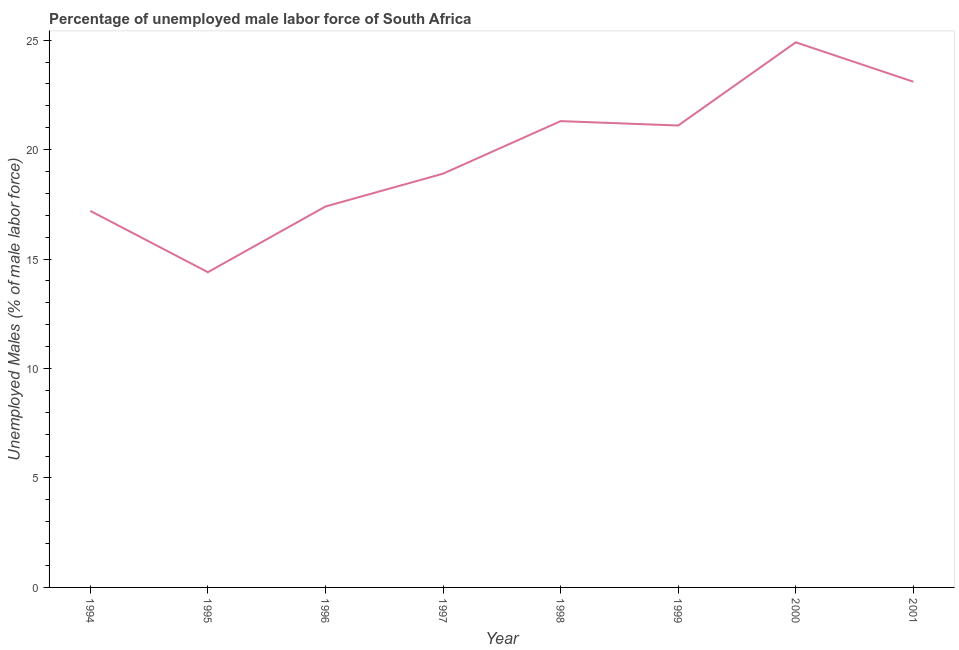What is the total unemployed male labour force in 1999?
Your response must be concise. 21.1. Across all years, what is the maximum total unemployed male labour force?
Your answer should be compact. 24.9. Across all years, what is the minimum total unemployed male labour force?
Offer a terse response. 14.4. In which year was the total unemployed male labour force minimum?
Make the answer very short. 1995. What is the sum of the total unemployed male labour force?
Offer a very short reply. 158.3. What is the difference between the total unemployed male labour force in 1998 and 1999?
Provide a short and direct response. 0.2. What is the average total unemployed male labour force per year?
Offer a terse response. 19.79. What is the median total unemployed male labour force?
Provide a short and direct response. 20. In how many years, is the total unemployed male labour force greater than 7 %?
Your answer should be compact. 8. Do a majority of the years between 1995 and 2000 (inclusive) have total unemployed male labour force greater than 19 %?
Your answer should be very brief. No. What is the ratio of the total unemployed male labour force in 1996 to that in 1997?
Provide a short and direct response. 0.92. Is the total unemployed male labour force in 1994 less than that in 1998?
Make the answer very short. Yes. What is the difference between the highest and the second highest total unemployed male labour force?
Offer a very short reply. 1.8. Is the sum of the total unemployed male labour force in 1996 and 1998 greater than the maximum total unemployed male labour force across all years?
Your answer should be compact. Yes. What is the difference between the highest and the lowest total unemployed male labour force?
Offer a terse response. 10.5. In how many years, is the total unemployed male labour force greater than the average total unemployed male labour force taken over all years?
Your answer should be compact. 4. What is the difference between two consecutive major ticks on the Y-axis?
Provide a short and direct response. 5. Does the graph contain any zero values?
Your answer should be compact. No. What is the title of the graph?
Your answer should be very brief. Percentage of unemployed male labor force of South Africa. What is the label or title of the X-axis?
Offer a very short reply. Year. What is the label or title of the Y-axis?
Offer a very short reply. Unemployed Males (% of male labor force). What is the Unemployed Males (% of male labor force) in 1994?
Provide a succinct answer. 17.2. What is the Unemployed Males (% of male labor force) in 1995?
Your answer should be compact. 14.4. What is the Unemployed Males (% of male labor force) of 1996?
Ensure brevity in your answer.  17.4. What is the Unemployed Males (% of male labor force) in 1997?
Your response must be concise. 18.9. What is the Unemployed Males (% of male labor force) in 1998?
Make the answer very short. 21.3. What is the Unemployed Males (% of male labor force) of 1999?
Keep it short and to the point. 21.1. What is the Unemployed Males (% of male labor force) in 2000?
Offer a very short reply. 24.9. What is the Unemployed Males (% of male labor force) in 2001?
Keep it short and to the point. 23.1. What is the difference between the Unemployed Males (% of male labor force) in 1994 and 1996?
Make the answer very short. -0.2. What is the difference between the Unemployed Males (% of male labor force) in 1994 and 1997?
Your response must be concise. -1.7. What is the difference between the Unemployed Males (% of male labor force) in 1994 and 1998?
Offer a very short reply. -4.1. What is the difference between the Unemployed Males (% of male labor force) in 1994 and 1999?
Provide a short and direct response. -3.9. What is the difference between the Unemployed Males (% of male labor force) in 1994 and 2001?
Make the answer very short. -5.9. What is the difference between the Unemployed Males (% of male labor force) in 1995 and 1996?
Offer a very short reply. -3. What is the difference between the Unemployed Males (% of male labor force) in 1995 and 1997?
Your response must be concise. -4.5. What is the difference between the Unemployed Males (% of male labor force) in 1995 and 1998?
Your response must be concise. -6.9. What is the difference between the Unemployed Males (% of male labor force) in 1995 and 1999?
Make the answer very short. -6.7. What is the difference between the Unemployed Males (% of male labor force) in 1995 and 2001?
Give a very brief answer. -8.7. What is the difference between the Unemployed Males (% of male labor force) in 1996 and 1998?
Ensure brevity in your answer.  -3.9. What is the difference between the Unemployed Males (% of male labor force) in 1996 and 2000?
Make the answer very short. -7.5. What is the difference between the Unemployed Males (% of male labor force) in 1997 and 1998?
Your response must be concise. -2.4. What is the difference between the Unemployed Males (% of male labor force) in 1997 and 1999?
Provide a succinct answer. -2.2. What is the difference between the Unemployed Males (% of male labor force) in 1997 and 2001?
Keep it short and to the point. -4.2. What is the difference between the Unemployed Males (% of male labor force) in 1998 and 1999?
Provide a short and direct response. 0.2. What is the difference between the Unemployed Males (% of male labor force) in 1999 and 2000?
Your response must be concise. -3.8. What is the ratio of the Unemployed Males (% of male labor force) in 1994 to that in 1995?
Give a very brief answer. 1.19. What is the ratio of the Unemployed Males (% of male labor force) in 1994 to that in 1996?
Your answer should be compact. 0.99. What is the ratio of the Unemployed Males (% of male labor force) in 1994 to that in 1997?
Make the answer very short. 0.91. What is the ratio of the Unemployed Males (% of male labor force) in 1994 to that in 1998?
Offer a very short reply. 0.81. What is the ratio of the Unemployed Males (% of male labor force) in 1994 to that in 1999?
Your response must be concise. 0.81. What is the ratio of the Unemployed Males (% of male labor force) in 1994 to that in 2000?
Make the answer very short. 0.69. What is the ratio of the Unemployed Males (% of male labor force) in 1994 to that in 2001?
Offer a very short reply. 0.74. What is the ratio of the Unemployed Males (% of male labor force) in 1995 to that in 1996?
Provide a succinct answer. 0.83. What is the ratio of the Unemployed Males (% of male labor force) in 1995 to that in 1997?
Ensure brevity in your answer.  0.76. What is the ratio of the Unemployed Males (% of male labor force) in 1995 to that in 1998?
Ensure brevity in your answer.  0.68. What is the ratio of the Unemployed Males (% of male labor force) in 1995 to that in 1999?
Ensure brevity in your answer.  0.68. What is the ratio of the Unemployed Males (% of male labor force) in 1995 to that in 2000?
Keep it short and to the point. 0.58. What is the ratio of the Unemployed Males (% of male labor force) in 1995 to that in 2001?
Provide a short and direct response. 0.62. What is the ratio of the Unemployed Males (% of male labor force) in 1996 to that in 1997?
Make the answer very short. 0.92. What is the ratio of the Unemployed Males (% of male labor force) in 1996 to that in 1998?
Your answer should be very brief. 0.82. What is the ratio of the Unemployed Males (% of male labor force) in 1996 to that in 1999?
Make the answer very short. 0.82. What is the ratio of the Unemployed Males (% of male labor force) in 1996 to that in 2000?
Provide a succinct answer. 0.7. What is the ratio of the Unemployed Males (% of male labor force) in 1996 to that in 2001?
Keep it short and to the point. 0.75. What is the ratio of the Unemployed Males (% of male labor force) in 1997 to that in 1998?
Offer a very short reply. 0.89. What is the ratio of the Unemployed Males (% of male labor force) in 1997 to that in 1999?
Make the answer very short. 0.9. What is the ratio of the Unemployed Males (% of male labor force) in 1997 to that in 2000?
Provide a succinct answer. 0.76. What is the ratio of the Unemployed Males (% of male labor force) in 1997 to that in 2001?
Offer a terse response. 0.82. What is the ratio of the Unemployed Males (% of male labor force) in 1998 to that in 2000?
Ensure brevity in your answer.  0.85. What is the ratio of the Unemployed Males (% of male labor force) in 1998 to that in 2001?
Offer a very short reply. 0.92. What is the ratio of the Unemployed Males (% of male labor force) in 1999 to that in 2000?
Offer a terse response. 0.85. What is the ratio of the Unemployed Males (% of male labor force) in 1999 to that in 2001?
Give a very brief answer. 0.91. What is the ratio of the Unemployed Males (% of male labor force) in 2000 to that in 2001?
Give a very brief answer. 1.08. 